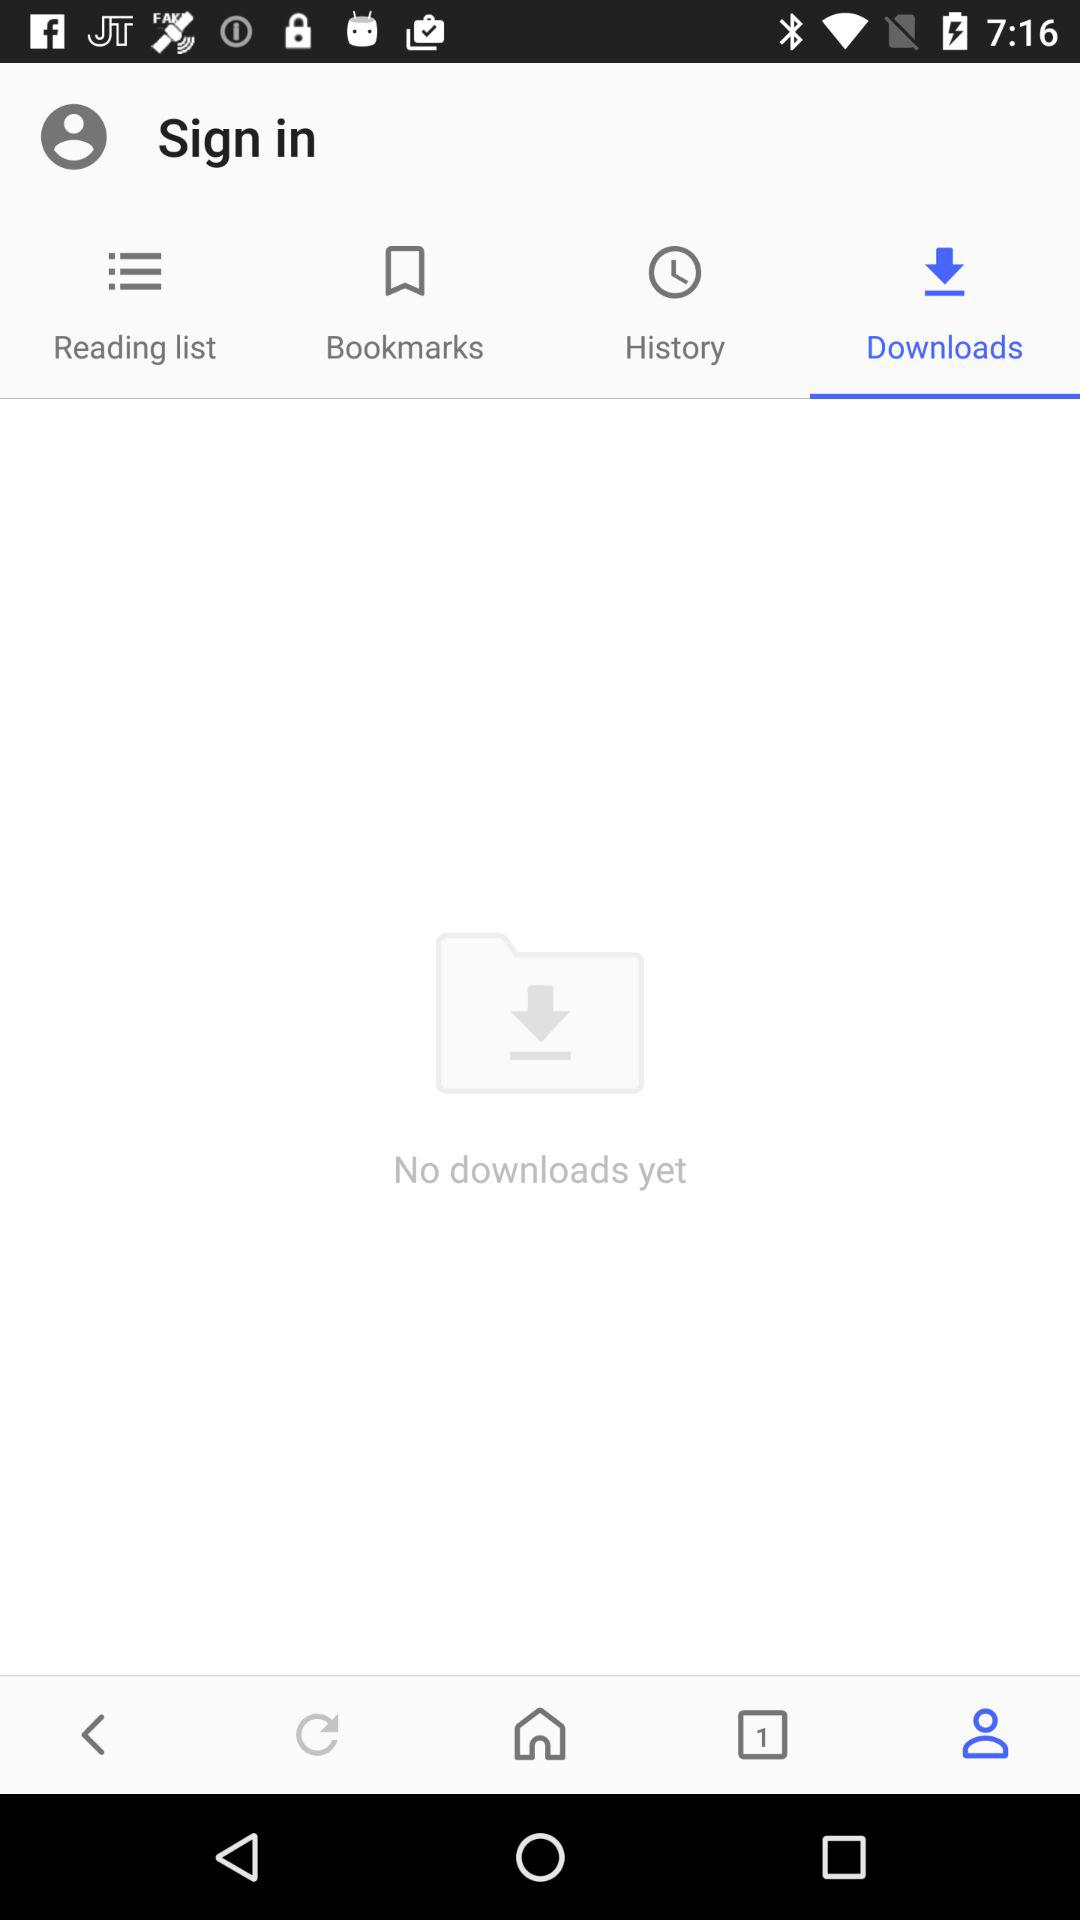Which option is selected? The selected options are "Downloads" and "Sign in". 